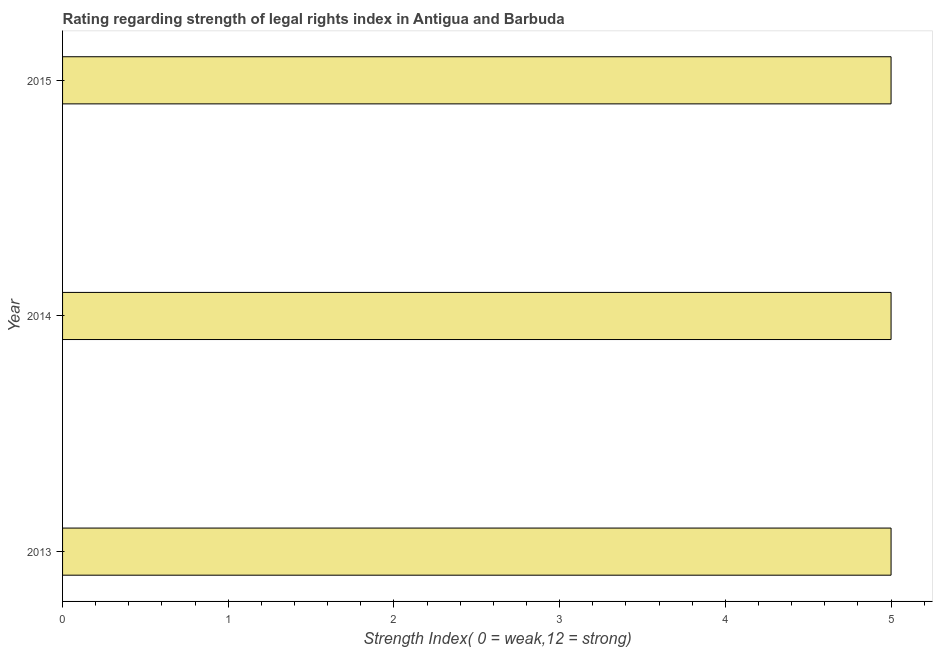Does the graph contain any zero values?
Ensure brevity in your answer.  No. Does the graph contain grids?
Ensure brevity in your answer.  No. What is the title of the graph?
Offer a very short reply. Rating regarding strength of legal rights index in Antigua and Barbuda. What is the label or title of the X-axis?
Your answer should be very brief. Strength Index( 0 = weak,12 = strong). What is the strength of legal rights index in 2014?
Your answer should be very brief. 5. Across all years, what is the maximum strength of legal rights index?
Your answer should be very brief. 5. What is the sum of the strength of legal rights index?
Your response must be concise. 15. What is the average strength of legal rights index per year?
Offer a terse response. 5. What is the median strength of legal rights index?
Provide a succinct answer. 5. In how many years, is the strength of legal rights index greater than 0.2 ?
Ensure brevity in your answer.  3. Do a majority of the years between 2015 and 2014 (inclusive) have strength of legal rights index greater than 1.4 ?
Provide a succinct answer. No. What is the ratio of the strength of legal rights index in 2013 to that in 2015?
Your answer should be very brief. 1. Is the difference between the strength of legal rights index in 2013 and 2014 greater than the difference between any two years?
Provide a succinct answer. Yes. What is the difference between the highest and the second highest strength of legal rights index?
Your answer should be compact. 0. Is the sum of the strength of legal rights index in 2013 and 2015 greater than the maximum strength of legal rights index across all years?
Keep it short and to the point. Yes. In how many years, is the strength of legal rights index greater than the average strength of legal rights index taken over all years?
Your response must be concise. 0. Are all the bars in the graph horizontal?
Your answer should be very brief. Yes. How many years are there in the graph?
Ensure brevity in your answer.  3. What is the Strength Index( 0 = weak,12 = strong) of 2013?
Give a very brief answer. 5. What is the difference between the Strength Index( 0 = weak,12 = strong) in 2014 and 2015?
Keep it short and to the point. 0. What is the ratio of the Strength Index( 0 = weak,12 = strong) in 2013 to that in 2014?
Make the answer very short. 1. What is the ratio of the Strength Index( 0 = weak,12 = strong) in 2014 to that in 2015?
Make the answer very short. 1. 